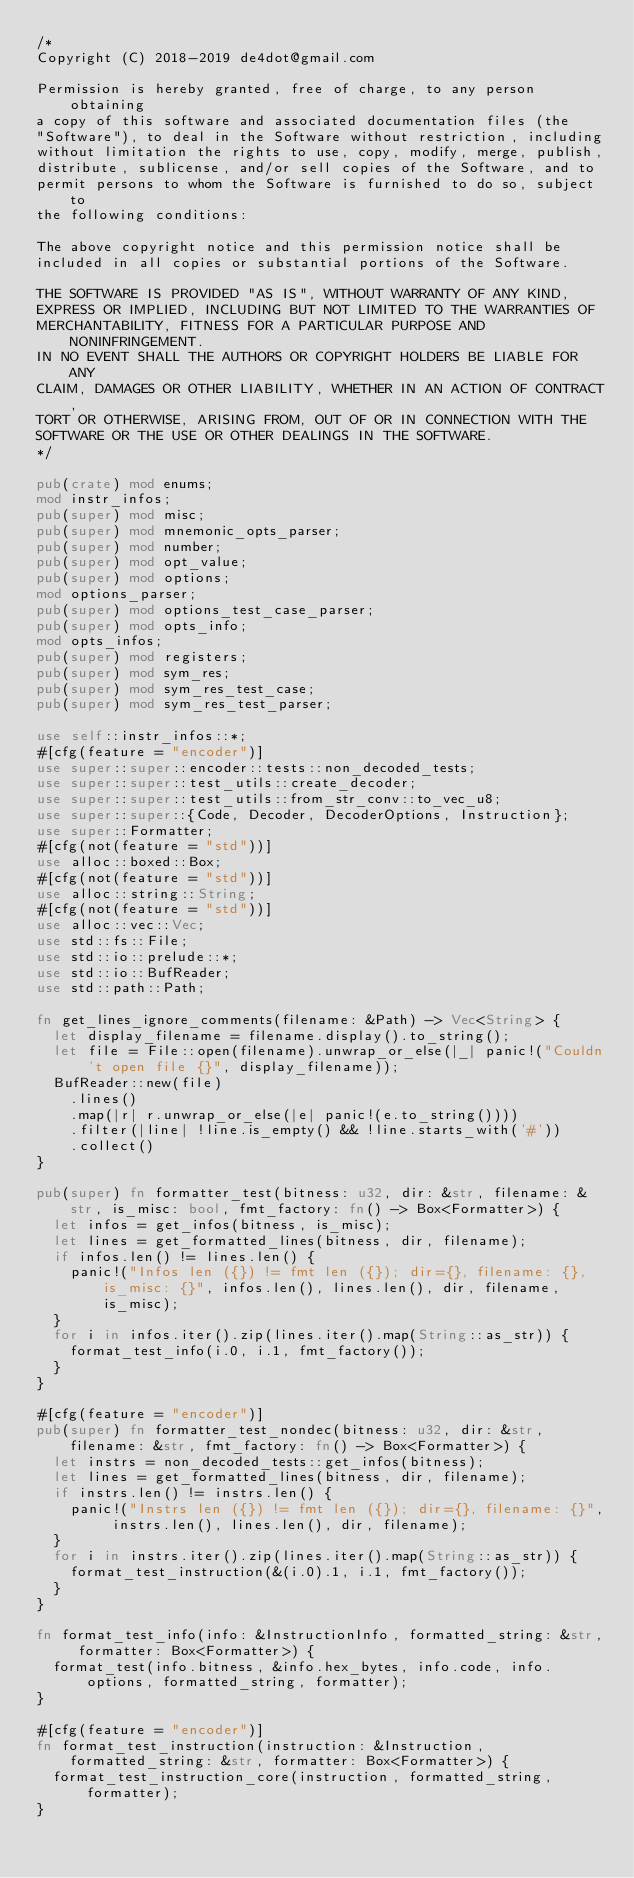<code> <loc_0><loc_0><loc_500><loc_500><_Rust_>/*
Copyright (C) 2018-2019 de4dot@gmail.com

Permission is hereby granted, free of charge, to any person obtaining
a copy of this software and associated documentation files (the
"Software"), to deal in the Software without restriction, including
without limitation the rights to use, copy, modify, merge, publish,
distribute, sublicense, and/or sell copies of the Software, and to
permit persons to whom the Software is furnished to do so, subject to
the following conditions:

The above copyright notice and this permission notice shall be
included in all copies or substantial portions of the Software.

THE SOFTWARE IS PROVIDED "AS IS", WITHOUT WARRANTY OF ANY KIND,
EXPRESS OR IMPLIED, INCLUDING BUT NOT LIMITED TO THE WARRANTIES OF
MERCHANTABILITY, FITNESS FOR A PARTICULAR PURPOSE AND NONINFRINGEMENT.
IN NO EVENT SHALL THE AUTHORS OR COPYRIGHT HOLDERS BE LIABLE FOR ANY
CLAIM, DAMAGES OR OTHER LIABILITY, WHETHER IN AN ACTION OF CONTRACT,
TORT OR OTHERWISE, ARISING FROM, OUT OF OR IN CONNECTION WITH THE
SOFTWARE OR THE USE OR OTHER DEALINGS IN THE SOFTWARE.
*/

pub(crate) mod enums;
mod instr_infos;
pub(super) mod misc;
pub(super) mod mnemonic_opts_parser;
pub(super) mod number;
pub(super) mod opt_value;
pub(super) mod options;
mod options_parser;
pub(super) mod options_test_case_parser;
pub(super) mod opts_info;
mod opts_infos;
pub(super) mod registers;
pub(super) mod sym_res;
pub(super) mod sym_res_test_case;
pub(super) mod sym_res_test_parser;

use self::instr_infos::*;
#[cfg(feature = "encoder")]
use super::super::encoder::tests::non_decoded_tests;
use super::super::test_utils::create_decoder;
use super::super::test_utils::from_str_conv::to_vec_u8;
use super::super::{Code, Decoder, DecoderOptions, Instruction};
use super::Formatter;
#[cfg(not(feature = "std"))]
use alloc::boxed::Box;
#[cfg(not(feature = "std"))]
use alloc::string::String;
#[cfg(not(feature = "std"))]
use alloc::vec::Vec;
use std::fs::File;
use std::io::prelude::*;
use std::io::BufReader;
use std::path::Path;

fn get_lines_ignore_comments(filename: &Path) -> Vec<String> {
	let display_filename = filename.display().to_string();
	let file = File::open(filename).unwrap_or_else(|_| panic!("Couldn't open file {}", display_filename));
	BufReader::new(file)
		.lines()
		.map(|r| r.unwrap_or_else(|e| panic!(e.to_string())))
		.filter(|line| !line.is_empty() && !line.starts_with('#'))
		.collect()
}

pub(super) fn formatter_test(bitness: u32, dir: &str, filename: &str, is_misc: bool, fmt_factory: fn() -> Box<Formatter>) {
	let infos = get_infos(bitness, is_misc);
	let lines = get_formatted_lines(bitness, dir, filename);
	if infos.len() != lines.len() {
		panic!("Infos len ({}) != fmt len ({}); dir={}, filename: {}, is_misc: {}", infos.len(), lines.len(), dir, filename, is_misc);
	}
	for i in infos.iter().zip(lines.iter().map(String::as_str)) {
		format_test_info(i.0, i.1, fmt_factory());
	}
}

#[cfg(feature = "encoder")]
pub(super) fn formatter_test_nondec(bitness: u32, dir: &str, filename: &str, fmt_factory: fn() -> Box<Formatter>) {
	let instrs = non_decoded_tests::get_infos(bitness);
	let lines = get_formatted_lines(bitness, dir, filename);
	if instrs.len() != instrs.len() {
		panic!("Instrs len ({}) != fmt len ({}); dir={}, filename: {}", instrs.len(), lines.len(), dir, filename);
	}
	for i in instrs.iter().zip(lines.iter().map(String::as_str)) {
		format_test_instruction(&(i.0).1, i.1, fmt_factory());
	}
}

fn format_test_info(info: &InstructionInfo, formatted_string: &str, formatter: Box<Formatter>) {
	format_test(info.bitness, &info.hex_bytes, info.code, info.options, formatted_string, formatter);
}

#[cfg(feature = "encoder")]
fn format_test_instruction(instruction: &Instruction, formatted_string: &str, formatter: Box<Formatter>) {
	format_test_instruction_core(instruction, formatted_string, formatter);
}
</code> 